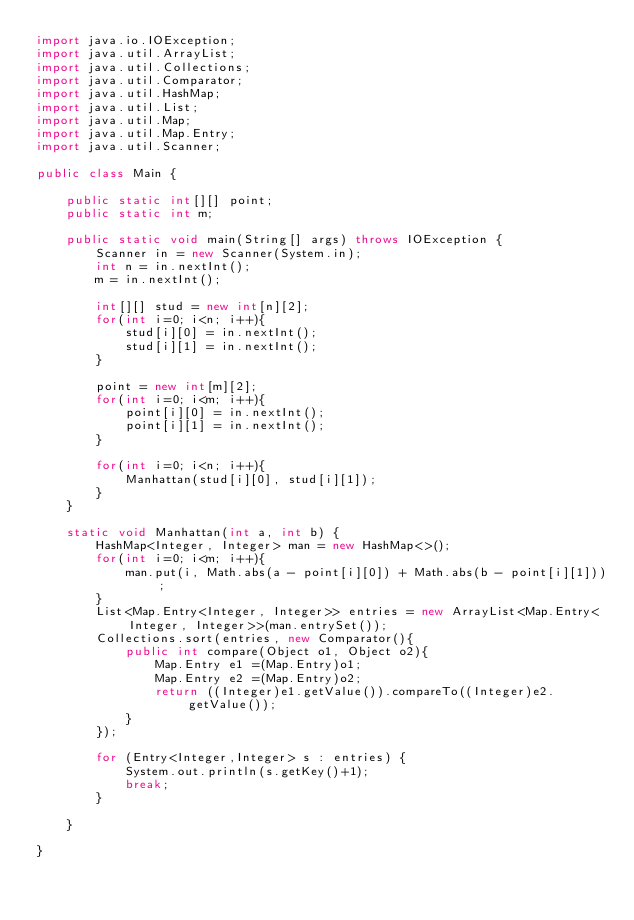<code> <loc_0><loc_0><loc_500><loc_500><_Java_>import java.io.IOException;
import java.util.ArrayList;
import java.util.Collections;
import java.util.Comparator;
import java.util.HashMap;
import java.util.List;
import java.util.Map;
import java.util.Map.Entry;
import java.util.Scanner;

public class Main {

	public static int[][] point;
	public static int m;

	public static void main(String[] args) throws IOException {
		Scanner in = new Scanner(System.in);
		int n = in.nextInt();
		m = in.nextInt();

		int[][] stud = new int[n][2];
		for(int i=0; i<n; i++){
			stud[i][0] = in.nextInt();
			stud[i][1] = in.nextInt();
		}

		point = new int[m][2];
		for(int i=0; i<m; i++){
			point[i][0] = in.nextInt();
			point[i][1] = in.nextInt();
		}

		for(int i=0; i<n; i++){
			Manhattan(stud[i][0], stud[i][1]);
		}
	}

	static void Manhattan(int a, int b) {
		HashMap<Integer, Integer> man = new HashMap<>();
		for(int i=0; i<m; i++){
			man.put(i, Math.abs(a - point[i][0]) + Math.abs(b - point[i][1]));
		}
		List<Map.Entry<Integer, Integer>> entries = new ArrayList<Map.Entry<Integer, Integer>>(man.entrySet());
		Collections.sort(entries, new Comparator(){
		    public int compare(Object o1, Object o2){
		        Map.Entry e1 =(Map.Entry)o1;
		        Map.Entry e2 =(Map.Entry)o2;
		        return ((Integer)e1.getValue()).compareTo((Integer)e2.getValue());
		    }
		});

		for (Entry<Integer,Integer> s : entries) {
            System.out.println(s.getKey()+1);
            break;
        }

	}

}

</code> 